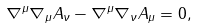<formula> <loc_0><loc_0><loc_500><loc_500>\nabla ^ { \mu } \nabla _ { \mu } A _ { \nu } - \nabla ^ { \mu } \nabla _ { \nu } A _ { \mu } = 0 ,</formula> 